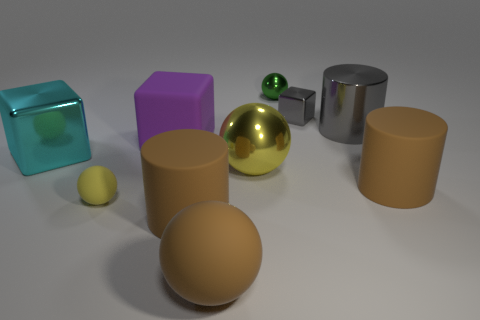There is another sphere that is the same color as the big metal sphere; what is it made of?
Your response must be concise. Rubber. What is the shape of the object that is the same color as the small matte ball?
Your response must be concise. Sphere. There is a large yellow thing that is made of the same material as the cyan cube; what is its shape?
Give a very brief answer. Sphere. There is a small yellow thing that is the same shape as the big yellow object; what material is it?
Your response must be concise. Rubber. There is a small thing that is in front of the tiny green ball and to the right of the tiny yellow thing; what color is it?
Your answer should be compact. Gray. The big purple thing has what shape?
Offer a terse response. Cube. Do the large cyan cube and the purple object have the same material?
Keep it short and to the point. No. Is the number of cyan metal objects that are in front of the large brown sphere the same as the number of tiny yellow rubber objects on the right side of the purple rubber block?
Ensure brevity in your answer.  Yes. There is a rubber cylinder on the right side of the shiny block behind the gray cylinder; is there a tiny cube in front of it?
Keep it short and to the point. No. Do the brown rubber sphere and the yellow rubber ball have the same size?
Make the answer very short. No. 